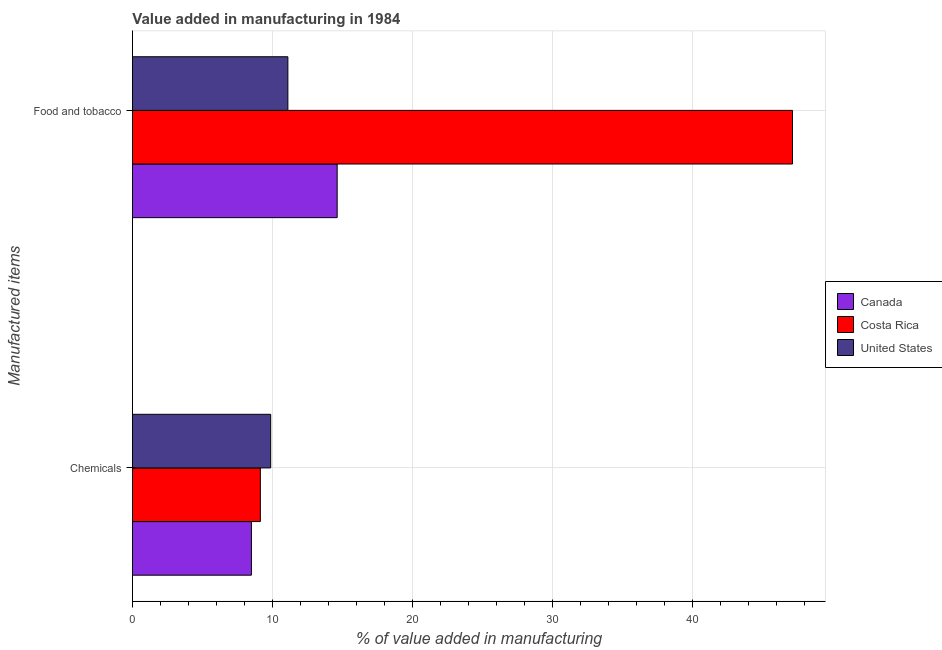How many different coloured bars are there?
Offer a very short reply. 3. How many groups of bars are there?
Make the answer very short. 2. Are the number of bars per tick equal to the number of legend labels?
Your answer should be very brief. Yes. Are the number of bars on each tick of the Y-axis equal?
Offer a very short reply. Yes. How many bars are there on the 1st tick from the top?
Your response must be concise. 3. How many bars are there on the 2nd tick from the bottom?
Make the answer very short. 3. What is the label of the 1st group of bars from the top?
Offer a terse response. Food and tobacco. What is the value added by  manufacturing chemicals in Costa Rica?
Give a very brief answer. 9.13. Across all countries, what is the maximum value added by manufacturing food and tobacco?
Give a very brief answer. 47.12. Across all countries, what is the minimum value added by  manufacturing chemicals?
Keep it short and to the point. 8.49. In which country was the value added by manufacturing food and tobacco maximum?
Provide a short and direct response. Costa Rica. What is the total value added by manufacturing food and tobacco in the graph?
Make the answer very short. 72.84. What is the difference between the value added by manufacturing food and tobacco in Costa Rica and that in United States?
Your answer should be compact. 36.03. What is the difference between the value added by  manufacturing chemicals in Canada and the value added by manufacturing food and tobacco in Costa Rica?
Make the answer very short. -38.63. What is the average value added by manufacturing food and tobacco per country?
Make the answer very short. 24.28. What is the difference between the value added by manufacturing food and tobacco and value added by  manufacturing chemicals in Costa Rica?
Offer a very short reply. 37.99. What is the ratio of the value added by manufacturing food and tobacco in Costa Rica to that in Canada?
Give a very brief answer. 3.22. Is the value added by  manufacturing chemicals in Costa Rica less than that in United States?
Your answer should be compact. Yes. What does the 1st bar from the bottom in Food and tobacco represents?
Offer a terse response. Canada. How many bars are there?
Your answer should be very brief. 6. Are all the bars in the graph horizontal?
Provide a short and direct response. Yes. How many countries are there in the graph?
Offer a terse response. 3. Does the graph contain any zero values?
Provide a succinct answer. No. Where does the legend appear in the graph?
Provide a succinct answer. Center right. How are the legend labels stacked?
Offer a terse response. Vertical. What is the title of the graph?
Make the answer very short. Value added in manufacturing in 1984. What is the label or title of the X-axis?
Ensure brevity in your answer.  % of value added in manufacturing. What is the label or title of the Y-axis?
Your answer should be compact. Manufactured items. What is the % of value added in manufacturing of Canada in Chemicals?
Your answer should be very brief. 8.49. What is the % of value added in manufacturing of Costa Rica in Chemicals?
Offer a terse response. 9.13. What is the % of value added in manufacturing in United States in Chemicals?
Give a very brief answer. 9.87. What is the % of value added in manufacturing in Canada in Food and tobacco?
Offer a terse response. 14.62. What is the % of value added in manufacturing of Costa Rica in Food and tobacco?
Make the answer very short. 47.12. What is the % of value added in manufacturing in United States in Food and tobacco?
Ensure brevity in your answer.  11.1. Across all Manufactured items, what is the maximum % of value added in manufacturing of Canada?
Give a very brief answer. 14.62. Across all Manufactured items, what is the maximum % of value added in manufacturing in Costa Rica?
Ensure brevity in your answer.  47.12. Across all Manufactured items, what is the maximum % of value added in manufacturing of United States?
Offer a very short reply. 11.1. Across all Manufactured items, what is the minimum % of value added in manufacturing in Canada?
Your response must be concise. 8.49. Across all Manufactured items, what is the minimum % of value added in manufacturing in Costa Rica?
Make the answer very short. 9.13. Across all Manufactured items, what is the minimum % of value added in manufacturing in United States?
Give a very brief answer. 9.87. What is the total % of value added in manufacturing of Canada in the graph?
Your response must be concise. 23.11. What is the total % of value added in manufacturing of Costa Rica in the graph?
Make the answer very short. 56.26. What is the total % of value added in manufacturing in United States in the graph?
Your answer should be very brief. 20.97. What is the difference between the % of value added in manufacturing in Canada in Chemicals and that in Food and tobacco?
Offer a terse response. -6.12. What is the difference between the % of value added in manufacturing in Costa Rica in Chemicals and that in Food and tobacco?
Give a very brief answer. -37.99. What is the difference between the % of value added in manufacturing in United States in Chemicals and that in Food and tobacco?
Make the answer very short. -1.23. What is the difference between the % of value added in manufacturing of Canada in Chemicals and the % of value added in manufacturing of Costa Rica in Food and tobacco?
Give a very brief answer. -38.63. What is the difference between the % of value added in manufacturing in Canada in Chemicals and the % of value added in manufacturing in United States in Food and tobacco?
Ensure brevity in your answer.  -2.6. What is the difference between the % of value added in manufacturing in Costa Rica in Chemicals and the % of value added in manufacturing in United States in Food and tobacco?
Your response must be concise. -1.97. What is the average % of value added in manufacturing in Canada per Manufactured items?
Offer a very short reply. 11.56. What is the average % of value added in manufacturing of Costa Rica per Manufactured items?
Keep it short and to the point. 28.13. What is the average % of value added in manufacturing of United States per Manufactured items?
Provide a short and direct response. 10.48. What is the difference between the % of value added in manufacturing in Canada and % of value added in manufacturing in Costa Rica in Chemicals?
Your answer should be compact. -0.64. What is the difference between the % of value added in manufacturing of Canada and % of value added in manufacturing of United States in Chemicals?
Your answer should be compact. -1.38. What is the difference between the % of value added in manufacturing in Costa Rica and % of value added in manufacturing in United States in Chemicals?
Your response must be concise. -0.74. What is the difference between the % of value added in manufacturing of Canada and % of value added in manufacturing of Costa Rica in Food and tobacco?
Offer a terse response. -32.51. What is the difference between the % of value added in manufacturing in Canada and % of value added in manufacturing in United States in Food and tobacco?
Your answer should be compact. 3.52. What is the difference between the % of value added in manufacturing of Costa Rica and % of value added in manufacturing of United States in Food and tobacco?
Offer a terse response. 36.03. What is the ratio of the % of value added in manufacturing in Canada in Chemicals to that in Food and tobacco?
Your answer should be compact. 0.58. What is the ratio of the % of value added in manufacturing in Costa Rica in Chemicals to that in Food and tobacco?
Offer a very short reply. 0.19. What is the ratio of the % of value added in manufacturing in United States in Chemicals to that in Food and tobacco?
Make the answer very short. 0.89. What is the difference between the highest and the second highest % of value added in manufacturing in Canada?
Ensure brevity in your answer.  6.12. What is the difference between the highest and the second highest % of value added in manufacturing of Costa Rica?
Your answer should be compact. 37.99. What is the difference between the highest and the second highest % of value added in manufacturing in United States?
Your response must be concise. 1.23. What is the difference between the highest and the lowest % of value added in manufacturing in Canada?
Your response must be concise. 6.12. What is the difference between the highest and the lowest % of value added in manufacturing in Costa Rica?
Your answer should be very brief. 37.99. What is the difference between the highest and the lowest % of value added in manufacturing in United States?
Ensure brevity in your answer.  1.23. 